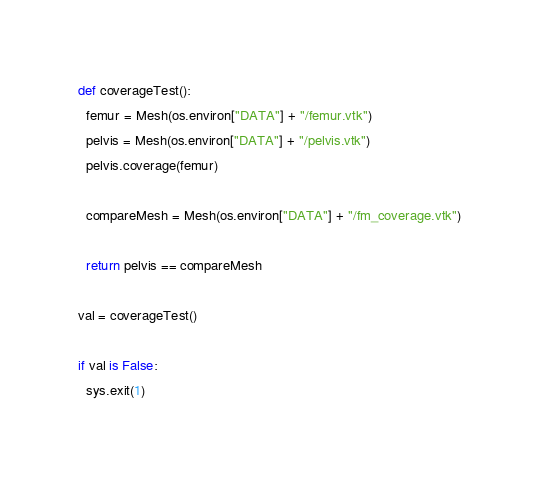Convert code to text. <code><loc_0><loc_0><loc_500><loc_500><_Python_>
def coverageTest():
  femur = Mesh(os.environ["DATA"] + "/femur.vtk")
  pelvis = Mesh(os.environ["DATA"] + "/pelvis.vtk")
  pelvis.coverage(femur)

  compareMesh = Mesh(os.environ["DATA"] + "/fm_coverage.vtk")

  return pelvis == compareMesh

val = coverageTest()

if val is False:
  sys.exit(1)
</code> 